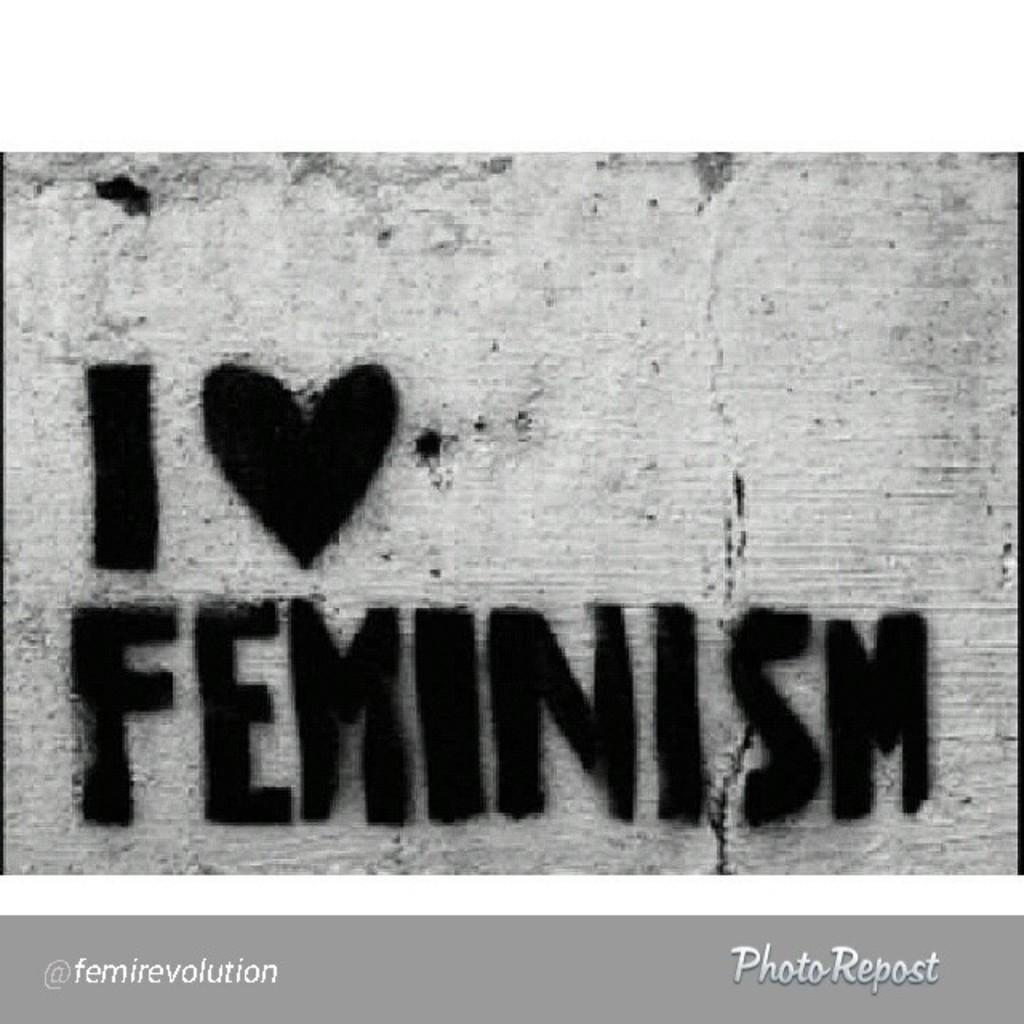<image>
Describe the image concisely. an I love feminism sign that is above a photo repost 